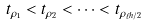<formula> <loc_0><loc_0><loc_500><loc_500>t _ { \rho _ { 1 } } < t _ { \rho _ { 2 } } < \cdots < t _ { \rho _ { \ell h / 2 } }</formula> 